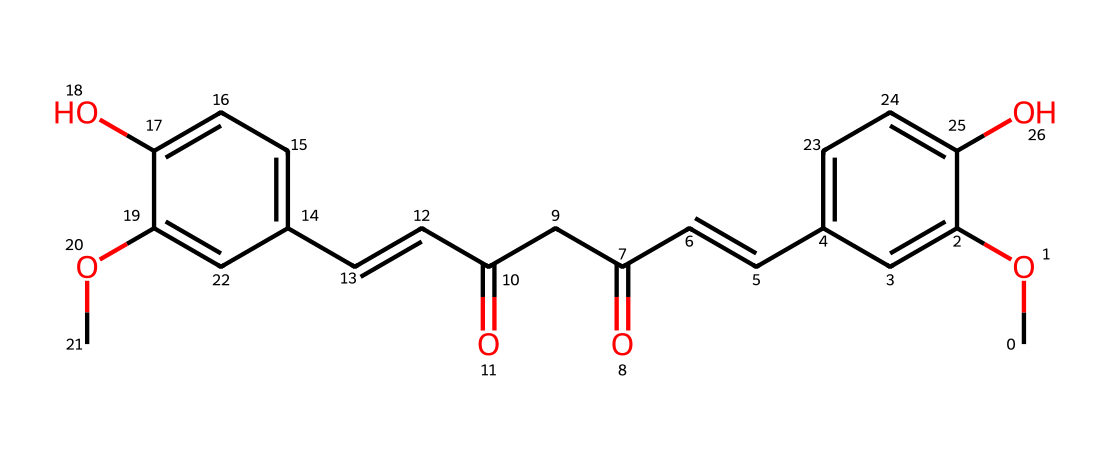What is the total number of carbon atoms in this molecule? By analyzing the SMILES representation, we can count each 'C' (carbon) character in the structure. There are 21 carbon atoms in total.
Answer: 21 How many hydroxyl (-OH) groups are present in this chemical structure? The presence of -OH groups can be identified by looking for 'O' characters next to '-' in the structure. In this case, there are two -OH groups.
Answer: 2 What type of functional groups are present in curcumin? Functional groups can be identified by their characteristic structures; in this case, we can see phenolic (aromatic rings) and alkenes (C=C), as well as carbonyl groups (C=O).
Answer: phenolic, alkenes, carbonyl Which part of this chemical contributes to its antioxidant properties? Antioxidants often have hydroxyl groups that can donate hydrogen atoms. The presence of two hydroxyl groups enhances the capacity to neutralize free radicals.
Answer: hydroxyl groups What is the molecular weight of the compound represented? Calculating molecular weight requires summing the atomic weights of all atoms present. The molecular weight of curcumin is approximately 368.38 g/mol.
Answer: 368.38 g/mol Are there any double bonds in the structure? Double bonds are represented by '/C=C/' in the SMILES notation. Counting these, we find there are two double bonds within the molecule.
Answer: 2 What role do the methoxy (-OCH3) groups play in this molecule? The methoxy groups increase the solubility of curcumin in organic solvents and enhance its antioxidant activity by stabilizing the molecular structure.
Answer: increase solubility, enhance activity 